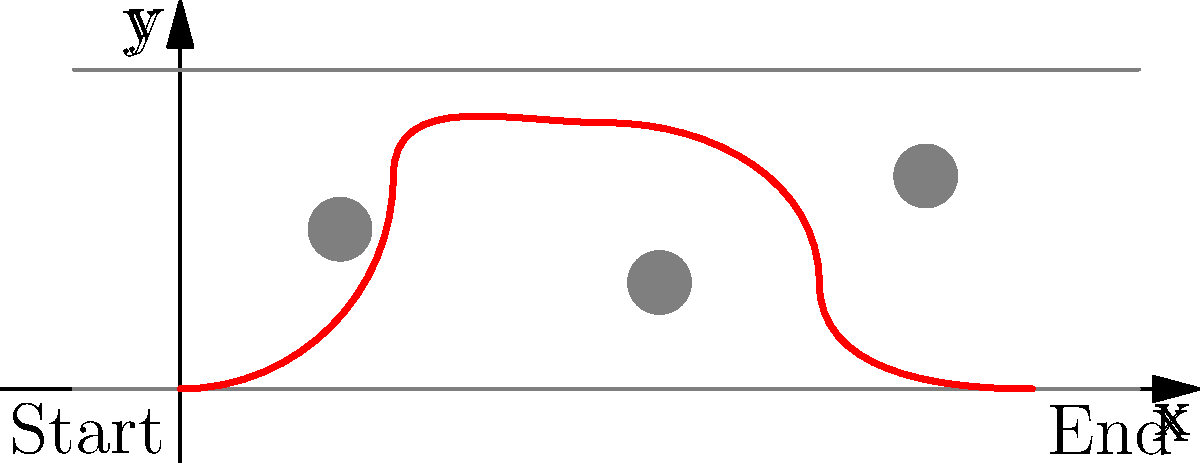In a thrilling car chase scene, you need to model the path of a getaway car weaving through obstacles on a city street. The car's path can be approximated by the following parametric equations:

$$x(t) = 2t$$
$$y(t) = \sin(\frac{\pi t}{2}) + \frac{1}{2}\sin(\pi t)$$

where $t$ is the time parameter ranging from 0 to 4 seconds. At what time $t$ does the car reach its maximum height (y-coordinate) on this path? To find the time when the car reaches its maximum height, we need to follow these steps:

1) The y-coordinate represents the height of the car. We need to find the maximum of the function:

   $$y(t) = \sin(\frac{\pi t}{2}) + \frac{1}{2}\sin(\pi t)$$

2) To find the maximum, we need to differentiate y(t) with respect to t and set it to zero:

   $$\frac{dy}{dt} = \frac{\pi}{2}\cos(\frac{\pi t}{2}) + \frac{\pi}{2}\cos(\pi t)$$

3) Set this equal to zero:

   $$\frac{\pi}{2}\cos(\frac{\pi t}{2}) + \frac{\pi}{2}\cos(\pi t) = 0$$

4) Simplify:

   $$\cos(\frac{\pi t}{2}) + \cos(\pi t) = 0$$

5) This equation is satisfied when $\frac{\pi t}{2} = \frac{\pi}{3}$ and $\pi t = \frac{2\pi}{3}$

6) Solving for t:

   $$t = \frac{2}{3}$$

7) We need to verify this is a maximum, not a minimum. We can do this by checking the second derivative is negative at this point, or by evaluating y(t) at this point and nearby points.

8) Checking y(0.5), y(2/3), and y(0.8):

   y(0.5) ≈ 1.3090
   y(2/3) ≈ 1.3662
   y(0.8) ≈ 1.3473

   This confirms that t = 2/3 gives a maximum.

Therefore, the car reaches its maximum height at t = 2/3 seconds.
Answer: $\frac{2}{3}$ seconds 